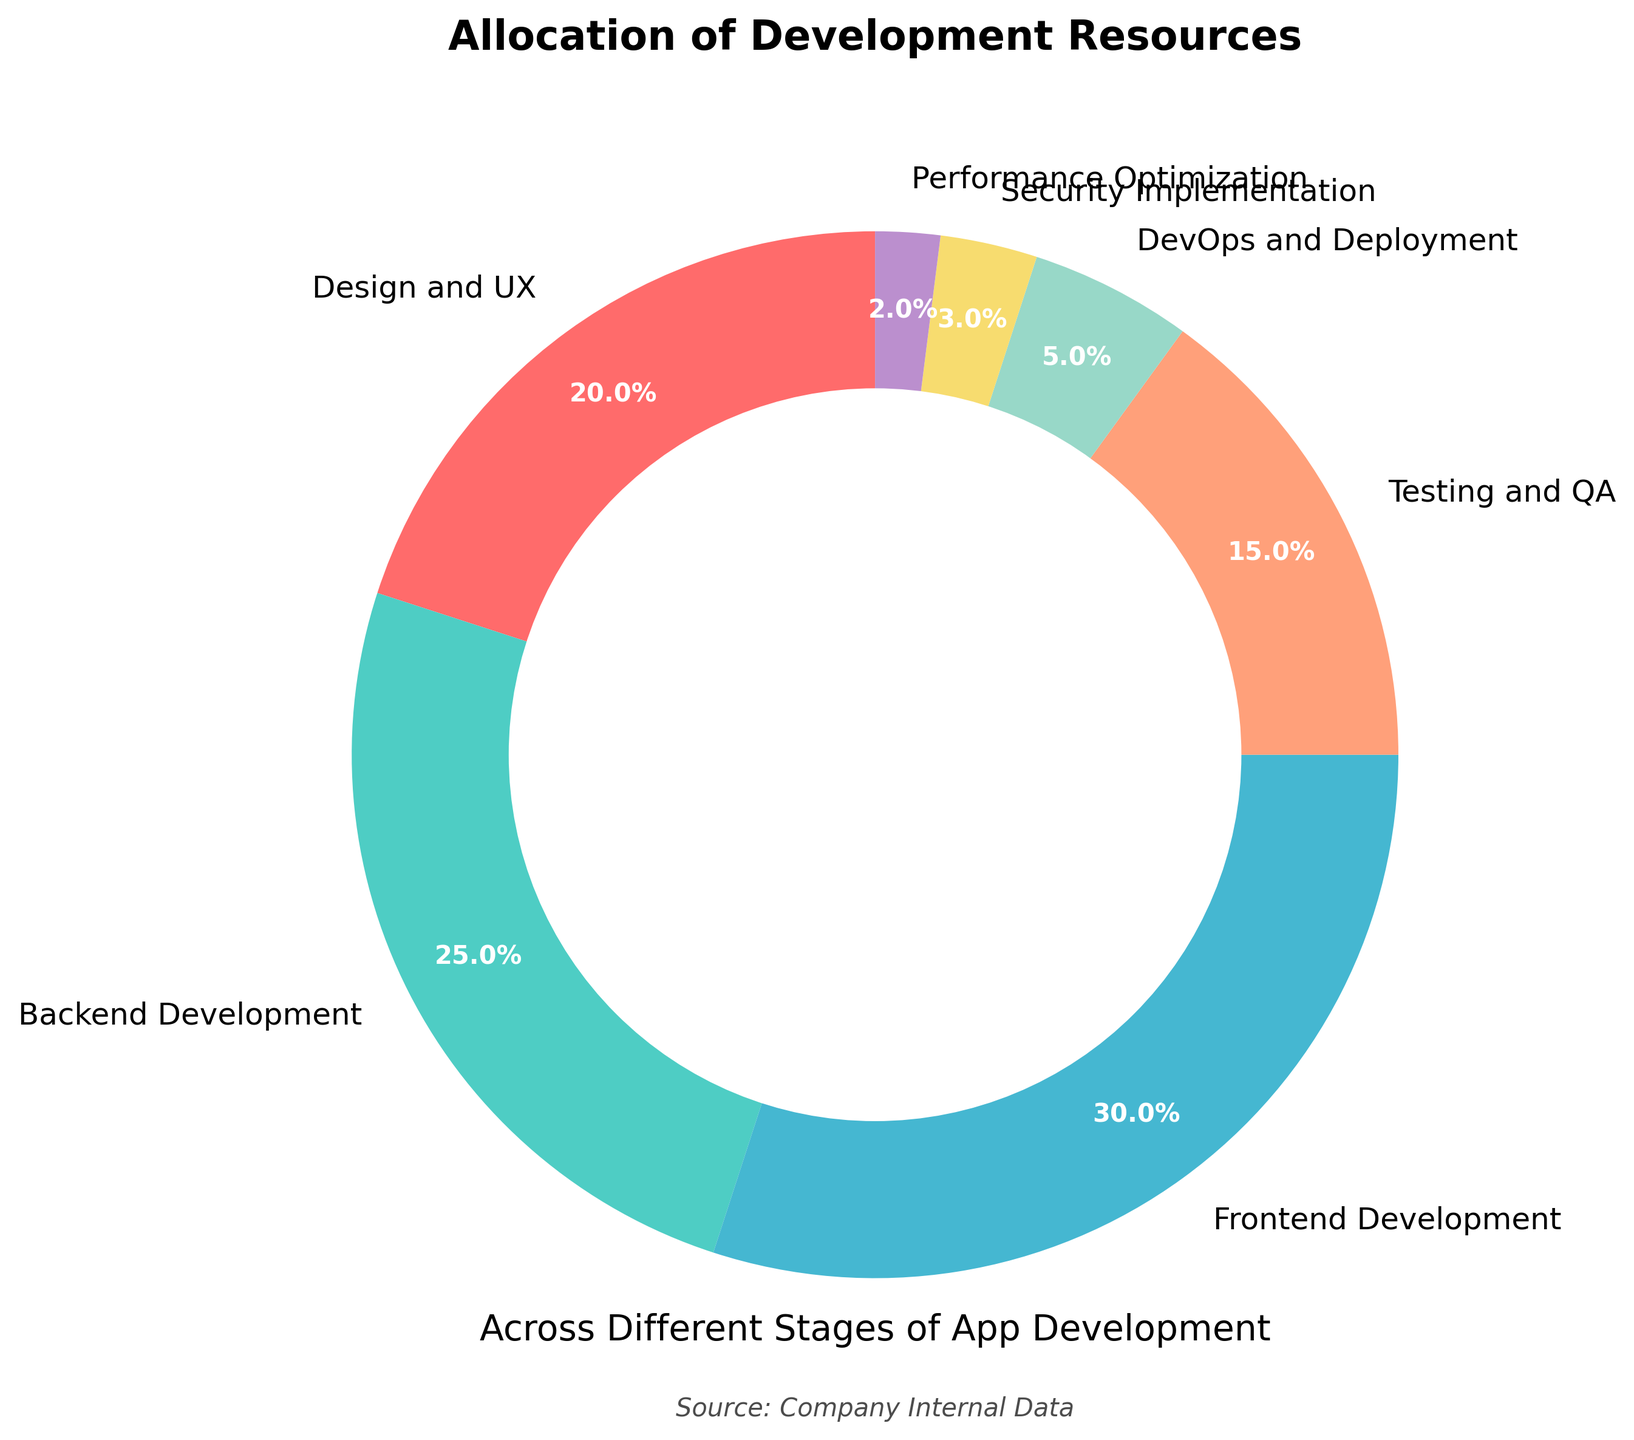What percentage of resources is allocated to the developmental stages that involve user interactions (Design and UX + Frontend Development)? We need to sum the percentages for "Design and UX" (20%) and "Frontend Development" (30%). Adding these two gives us 20 + 30 = 50%.
Answer: 50% Which developmental stage receives the highest allocation of resources? By examining the sectors of the pie chart, "Frontend Development" has the largest slice, representing 30% of the resources.
Answer: Frontend Development How much more is allocated to Backend Development compared to Security Implementation? We need to subtract the percentage for "Security Implementation" (3%) from "Backend Development" (25%). So, 25 - 3 = 22%.
Answer: 22% What is the total percentage of resources allocated to Testing and QA, DevOps and Deployment, and Performance Optimization combined? We sum the percentages for "Testing and QA" (15%), "DevOps and Deployment" (5%), and "Performance Optimization" (2%). Adding these three gives us 15 + 5 + 2 = 22%.
Answer: 22% Which stages have less than 5% resource allocation and what are their percentages? We look for slices representing less than 5% on the pie chart: "DevOps and Deployment" (5%), "Security Implementation" (3%), and "Performance Optimization" (2%).
Answer: Security Implementation (3%) and Performance Optimization (2%) Between Testing and QA and DevOps and Deployment, which stage has more resources allocated and by how much? We subtract the percentage for "DevOps and Deployment" (5%) from "Testing and QA" (15%). So, 15 - 5 = 10%.
Answer: Testing and QA by 10% Is the combined resource allocation for Security Implementation and Performance Optimization greater or less than that for DevOps and Deployment? We sum the percentages for "Security Implementation" (3%) and "Performance Optimization" (2%), which equals 5%. Since "DevOps and Deployment" is also 5%, the allocations are equal.
Answer: Equal How much of the total resources are allocated to stages focusing on implementation (Backend Development, Frontend Development, DevOps and Deployment)? Summing the percentages for "Backend Development" (25%), "Frontend Development" (30%), and "DevOps and Deployment" (5%) gives us 25 + 30 + 5 = 60%.
Answer: 60% What is the difference in resource allocation between Design and UX and Security Implementation? Subtract the percentage for "Security Implementation" (3%) from "Design and UX" (20%). So, 20 - 3 = 17%.
Answer: 17% Which developmental stage has the smallest allocation of resources and what is its percentage? By checking the smallest slice on the pie chart, "Performance Optimization" has the smallest allocation with 2%.
Answer: Performance Optimization (2%) 